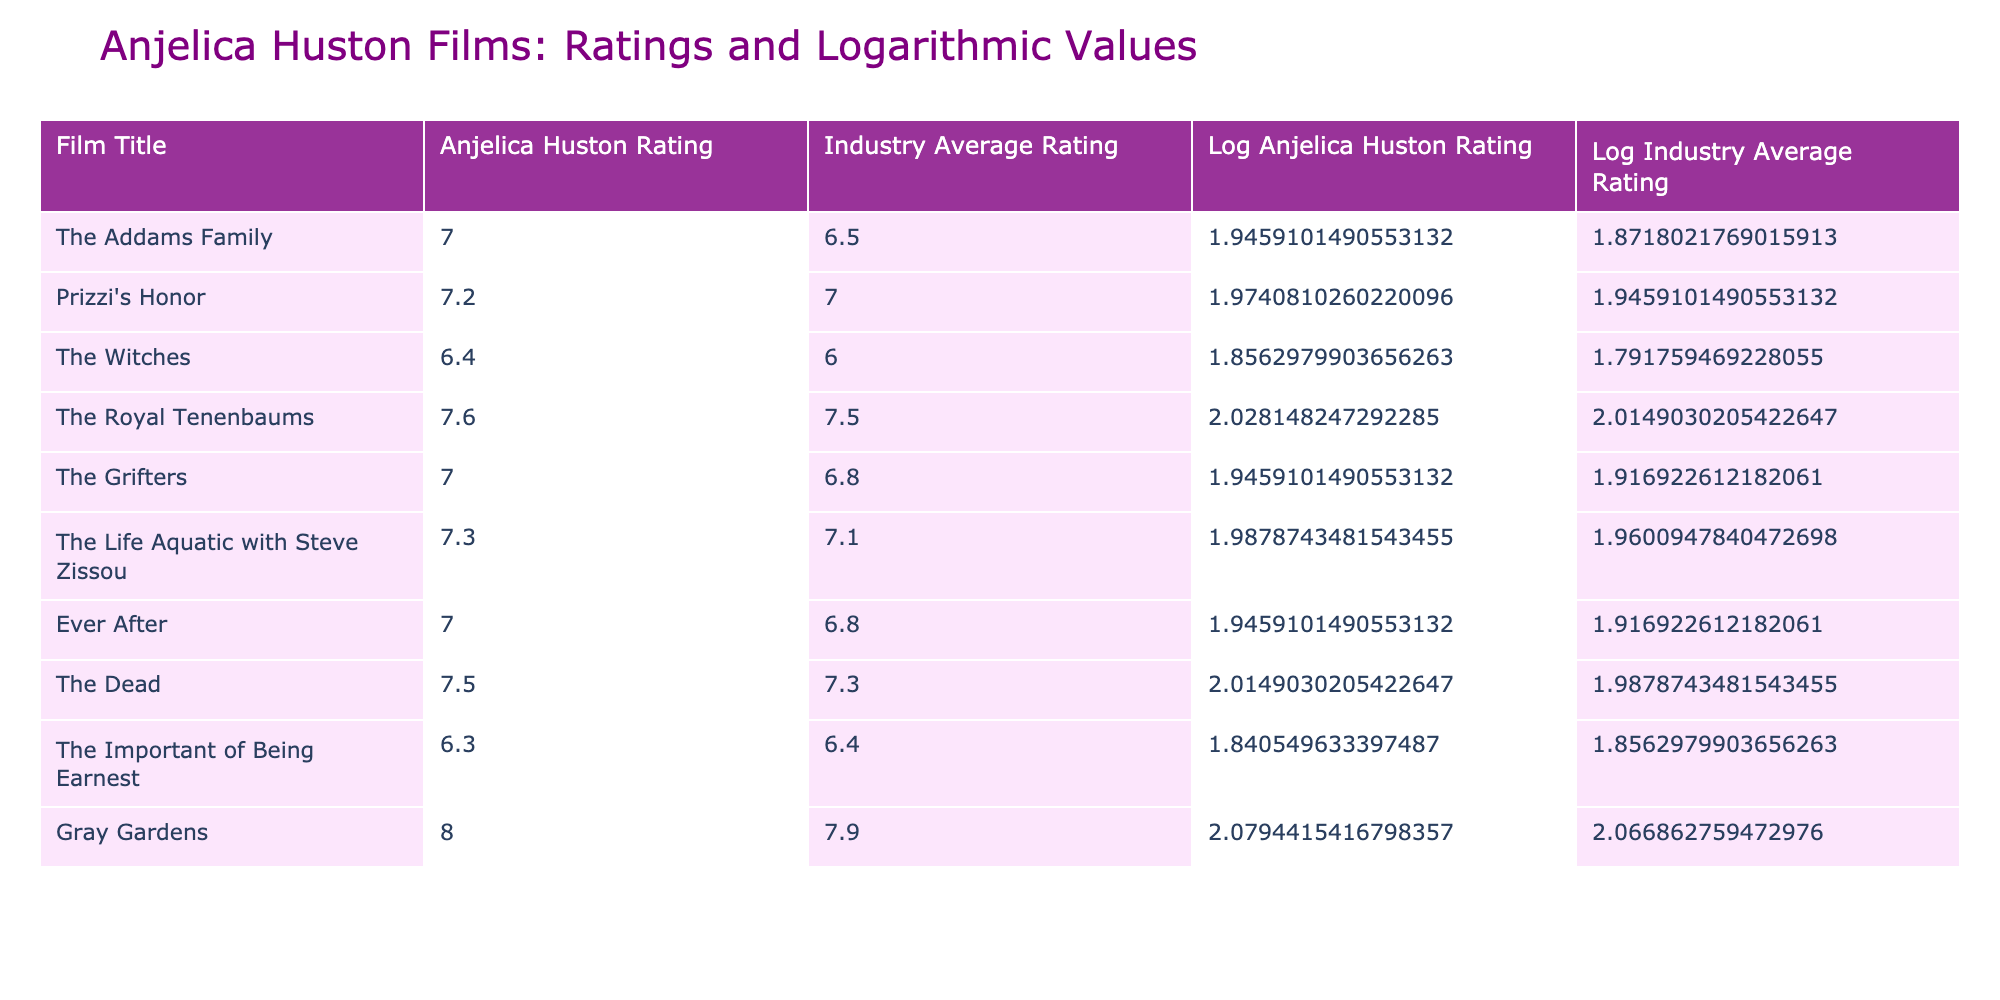What is the rating of "The Royal Tenenbaums"? The table lists "The Royal Tenenbaums" with an Anjelica Huston Rating of 7.6.
Answer: 7.6 Which film has the highest Anjelica Huston Rating? By reviewing the Anjelica Huston Ratings, "Gray Gardens" stands out with a rating of 8.0, which is the highest among the films listed.
Answer: 8.0 Is Anjelica Huston’s rating for "The Witches" higher than the industry average? "The Witches" has an Anjelica Huston Rating of 6.4 and an Industry Average Rating of 6.0. Since 6.4 is greater than 6.0, it confirms Anjelica Huston's rating is higher than the industry average.
Answer: Yes What is the difference between Anjelica Huston's rating and the industry average for "Prizzi's Honor"? The value for "Prizzi's Honor" shows that Anjelica Huston's rating is 7.2 and the industry average is 7.0. The difference can be calculated as 7.2 - 7.0 = 0.2.
Answer: 0.2 What is the average Anjelica Huston Rating across all films? To find the average Anjelica Huston Rating, you sum all the ratings: (7.0 + 7.2 + 6.4 + 7.6 + 7.0 + 7.3 + 7.0 + 7.5 + 6.3 + 8.0) = 70.5. The total number of films is 10, so the average is 70.5/10 = 7.05.
Answer: 7.05 Which film has the smallest difference between Anjelica Huston's rating and the industry average? By examining the differences, "The Important of Being Earnest" shows Anjelica Huston's rating of 6.3 and an industry average of 6.4, giving a difference of 0.1. This is the smallest among the films.
Answer: "The Important of Being Earnest" Does "The Life Aquatic with Steve Zissou" have a higher rating than "Ever After"? Comparing the two films, "The Life Aquatic with Steve Zissou" has a rating of 7.3 while "Ever After" has a rating of 7.0. Since 7.3 is greater than 7.0, it confirms that "The Life Aquatic with Steve Zissou" has a higher rating.
Answer: Yes What are the logarithmic values for "The Grifters"? The table shows that the Log Anjelica Huston Rating for "The Grifters" is approximately 1.9459, and the Log Industry Average Rating is approximately 1.8542.
Answer: 1.9459 and 1.8542 What is the combined Anjelica Huston Rating of films with a rating above 7.0? The films with ratings above 7.0 are "The Royal Tenenbaums" (7.6), "Prizzi's Honor" (7.2), "The Life Aquatic with Steve Zissou" (7.3), "The Dead" (7.5), and "Gray Gardens" (8.0). Summing these gives 7.6 + 7.2 + 7.3 + 7.5 + 8.0 = 37.6.
Answer: 37.6 